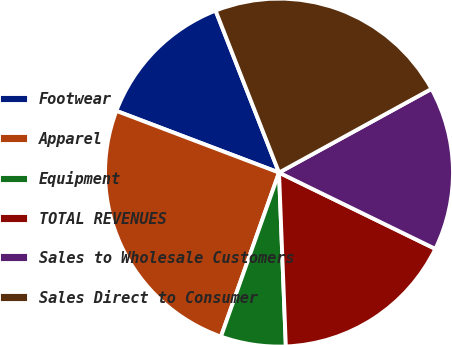Convert chart to OTSL. <chart><loc_0><loc_0><loc_500><loc_500><pie_chart><fcel>Footwear<fcel>Apparel<fcel>Equipment<fcel>TOTAL REVENUES<fcel>Sales to Wholesale Customers<fcel>Sales Direct to Consumer<nl><fcel>13.29%<fcel>25.36%<fcel>6.04%<fcel>17.15%<fcel>15.22%<fcel>22.95%<nl></chart> 